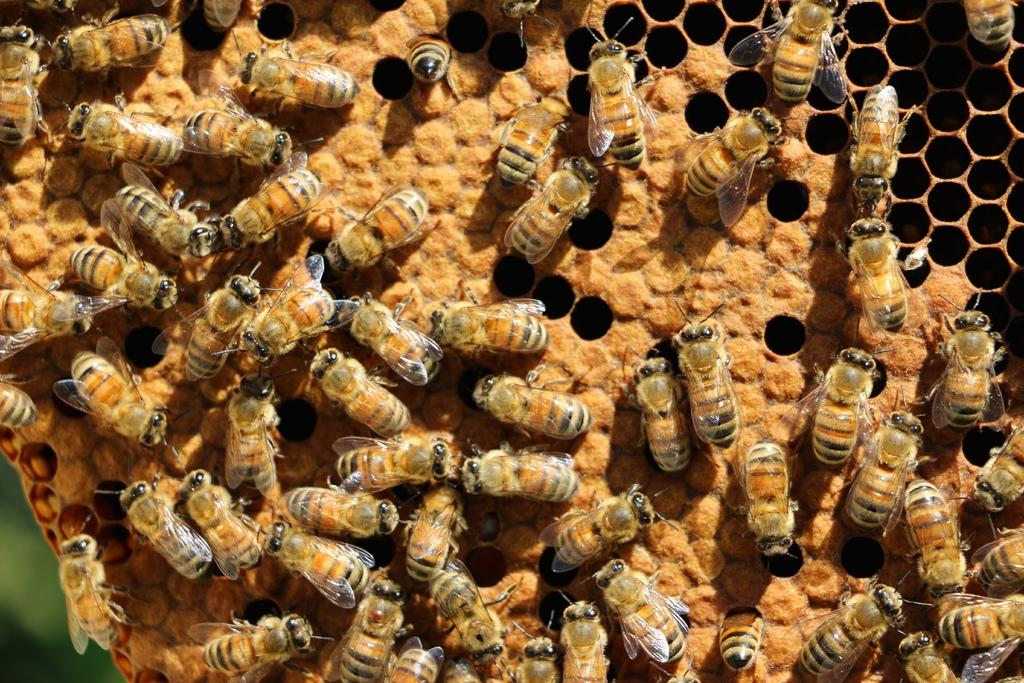What type of creatures are present in the image? There is a group of insects in the image. What color is the girl's hair in the image? There is no girl present in the image; it features a group of insects. How many balls are visible in the image? There are no balls present in the image; it features a group of insects. 